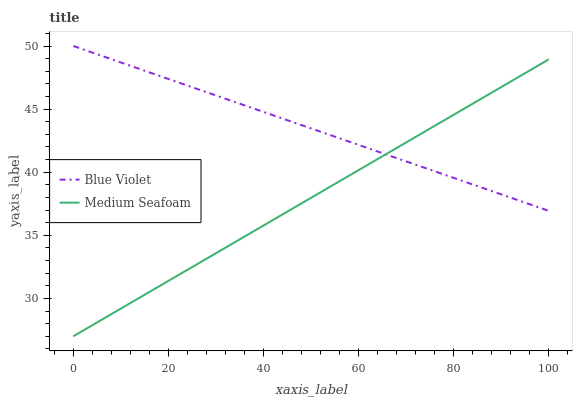Does Medium Seafoam have the minimum area under the curve?
Answer yes or no. Yes. Does Blue Violet have the maximum area under the curve?
Answer yes or no. Yes. Does Blue Violet have the minimum area under the curve?
Answer yes or no. No. Is Blue Violet the smoothest?
Answer yes or no. Yes. Is Medium Seafoam the roughest?
Answer yes or no. Yes. Is Blue Violet the roughest?
Answer yes or no. No. Does Medium Seafoam have the lowest value?
Answer yes or no. Yes. Does Blue Violet have the lowest value?
Answer yes or no. No. Does Blue Violet have the highest value?
Answer yes or no. Yes. Does Medium Seafoam intersect Blue Violet?
Answer yes or no. Yes. Is Medium Seafoam less than Blue Violet?
Answer yes or no. No. Is Medium Seafoam greater than Blue Violet?
Answer yes or no. No. 